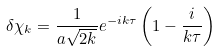<formula> <loc_0><loc_0><loc_500><loc_500>\delta \chi _ { k } = \frac { 1 } { a \sqrt { 2 k } } e ^ { - i k \tau } \left ( 1 - \frac { i } { k \tau } \right )</formula> 